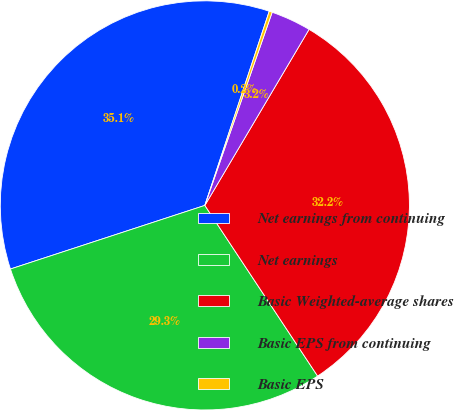<chart> <loc_0><loc_0><loc_500><loc_500><pie_chart><fcel>Net earnings from continuing<fcel>Net earnings<fcel>Basic Weighted-average shares<fcel>Basic EPS from continuing<fcel>Basic EPS<nl><fcel>35.13%<fcel>29.26%<fcel>32.2%<fcel>3.17%<fcel>0.24%<nl></chart> 